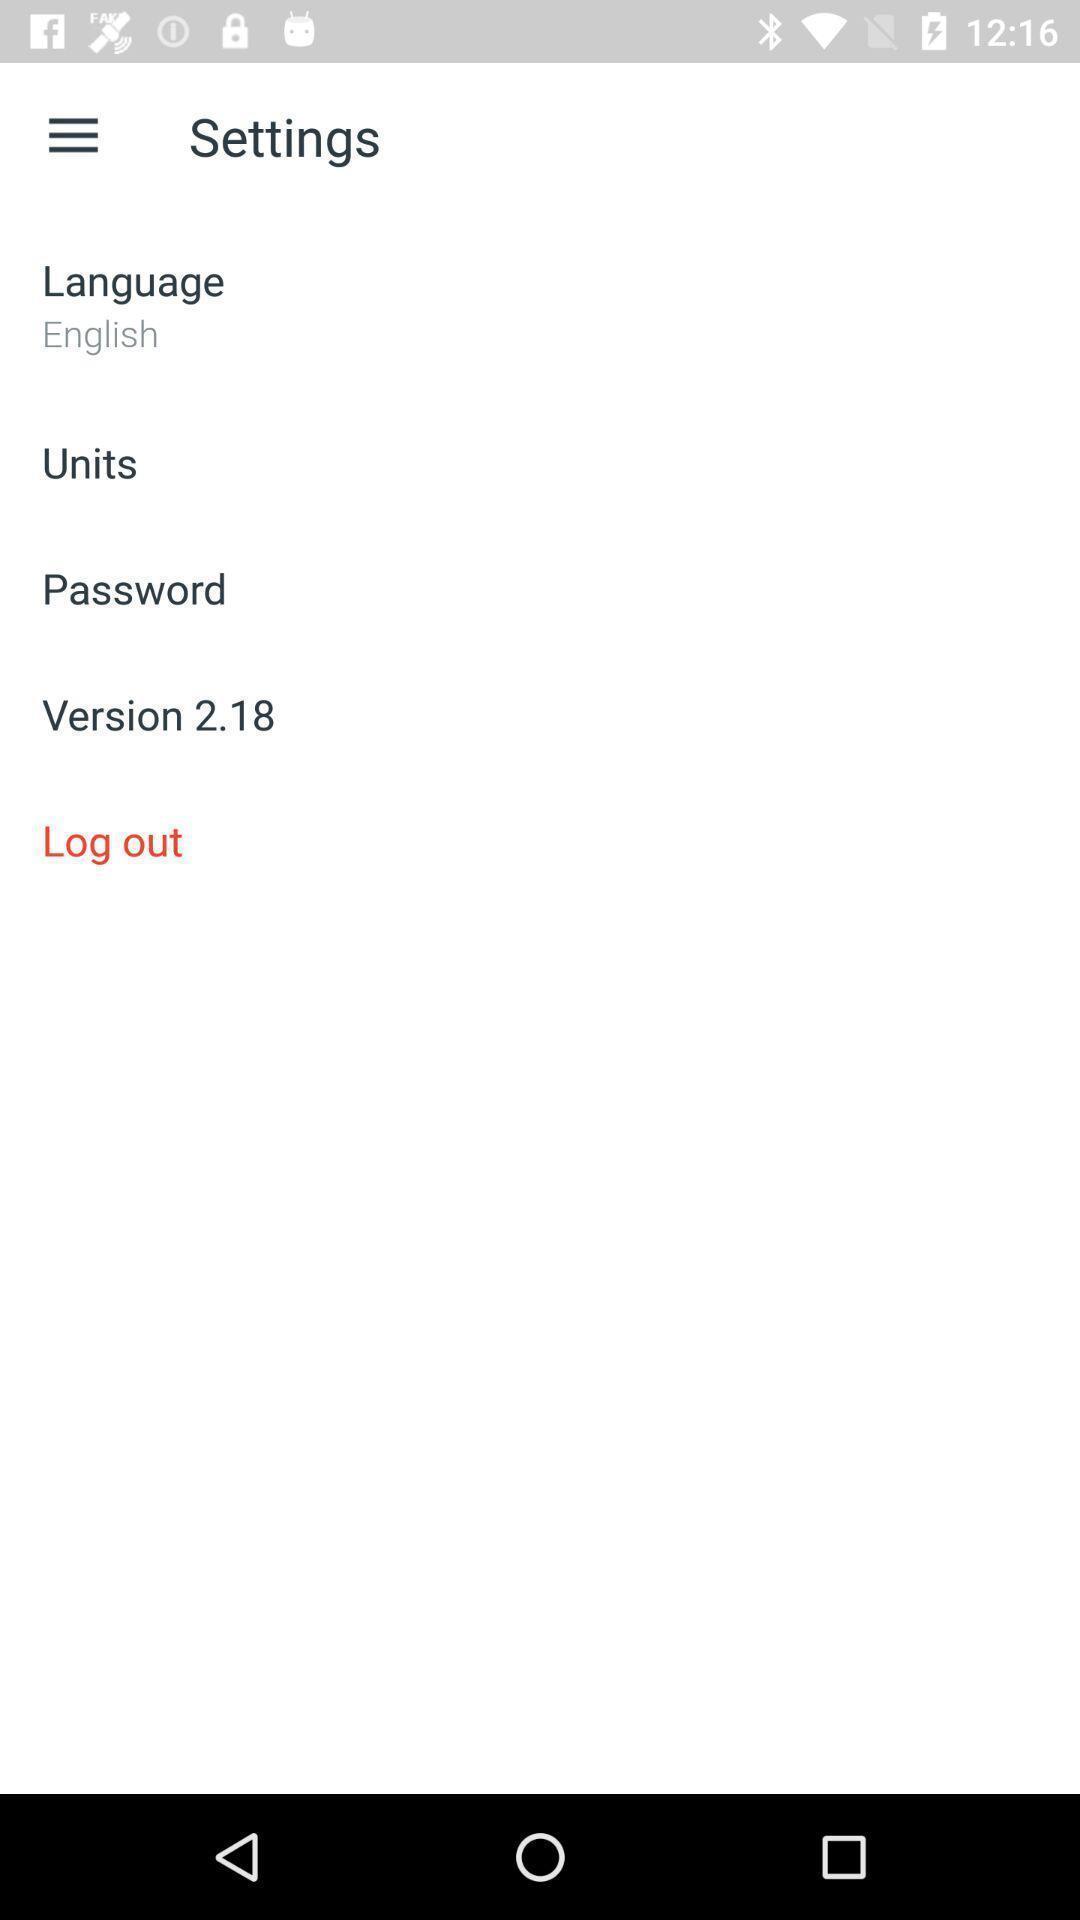Explain the elements present in this screenshot. Settings page with various other options and with logout button. 